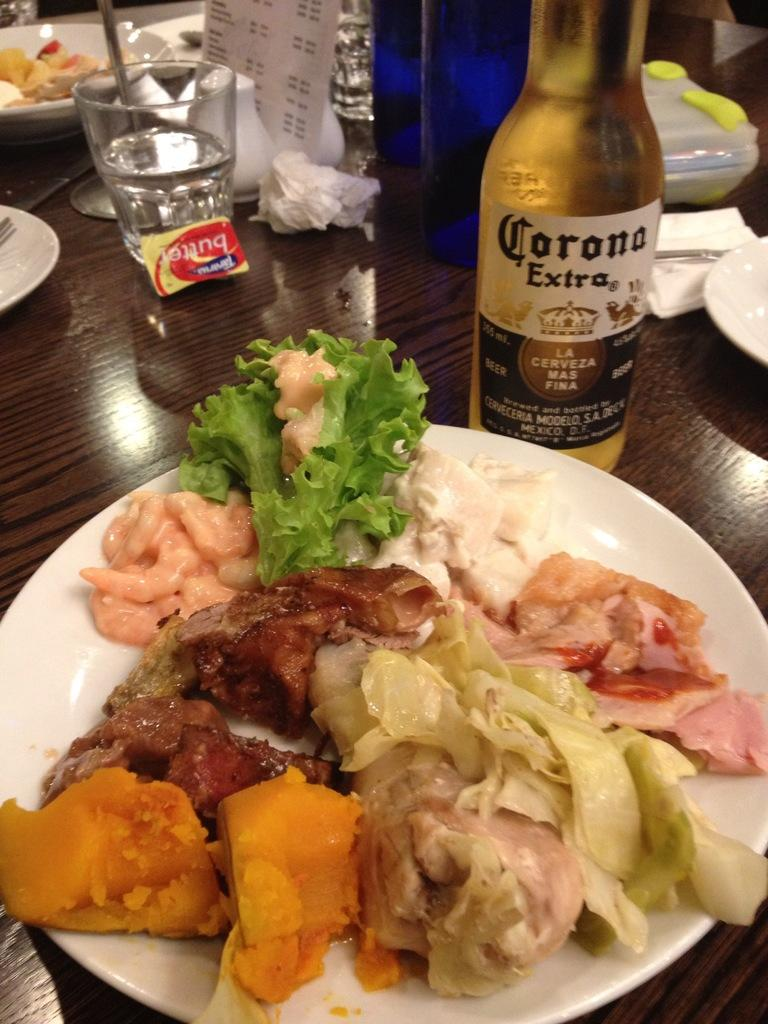<image>
Describe the image concisely. Bottle with a label that says "Corona Extra" on it. 